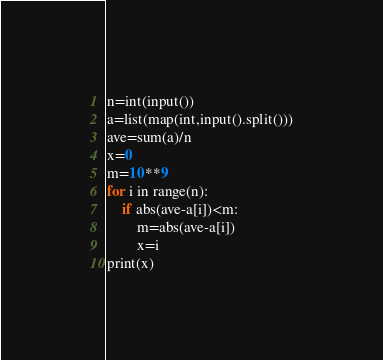Convert code to text. <code><loc_0><loc_0><loc_500><loc_500><_Python_>n=int(input())
a=list(map(int,input().split()))
ave=sum(a)/n
x=0
m=10**9
for i in range(n):
    if abs(ave-a[i])<m:
        m=abs(ave-a[i])
        x=i
print(x)</code> 